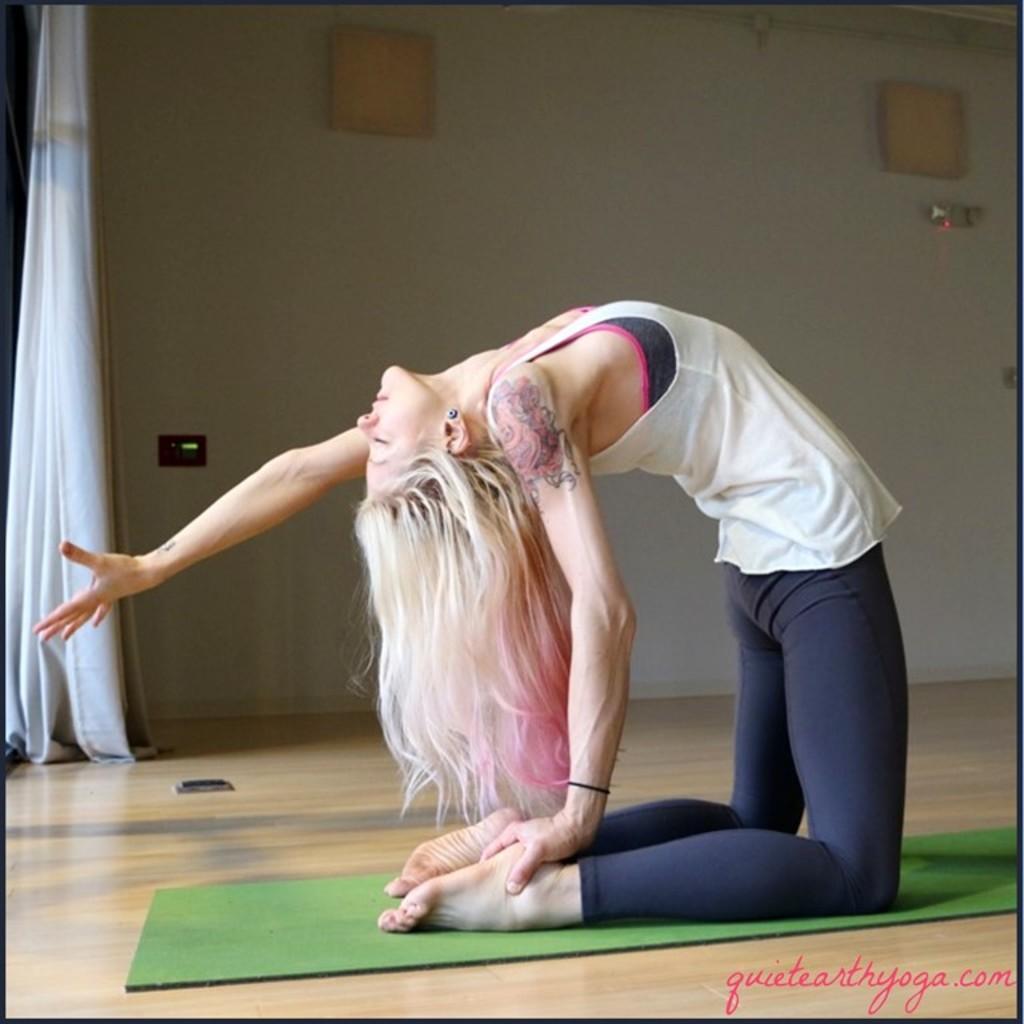How would you summarize this image in a sentence or two? In the foreground of this picture, there is a woman doing exercise on a mat. In the background, there is a wall and the curtain. 